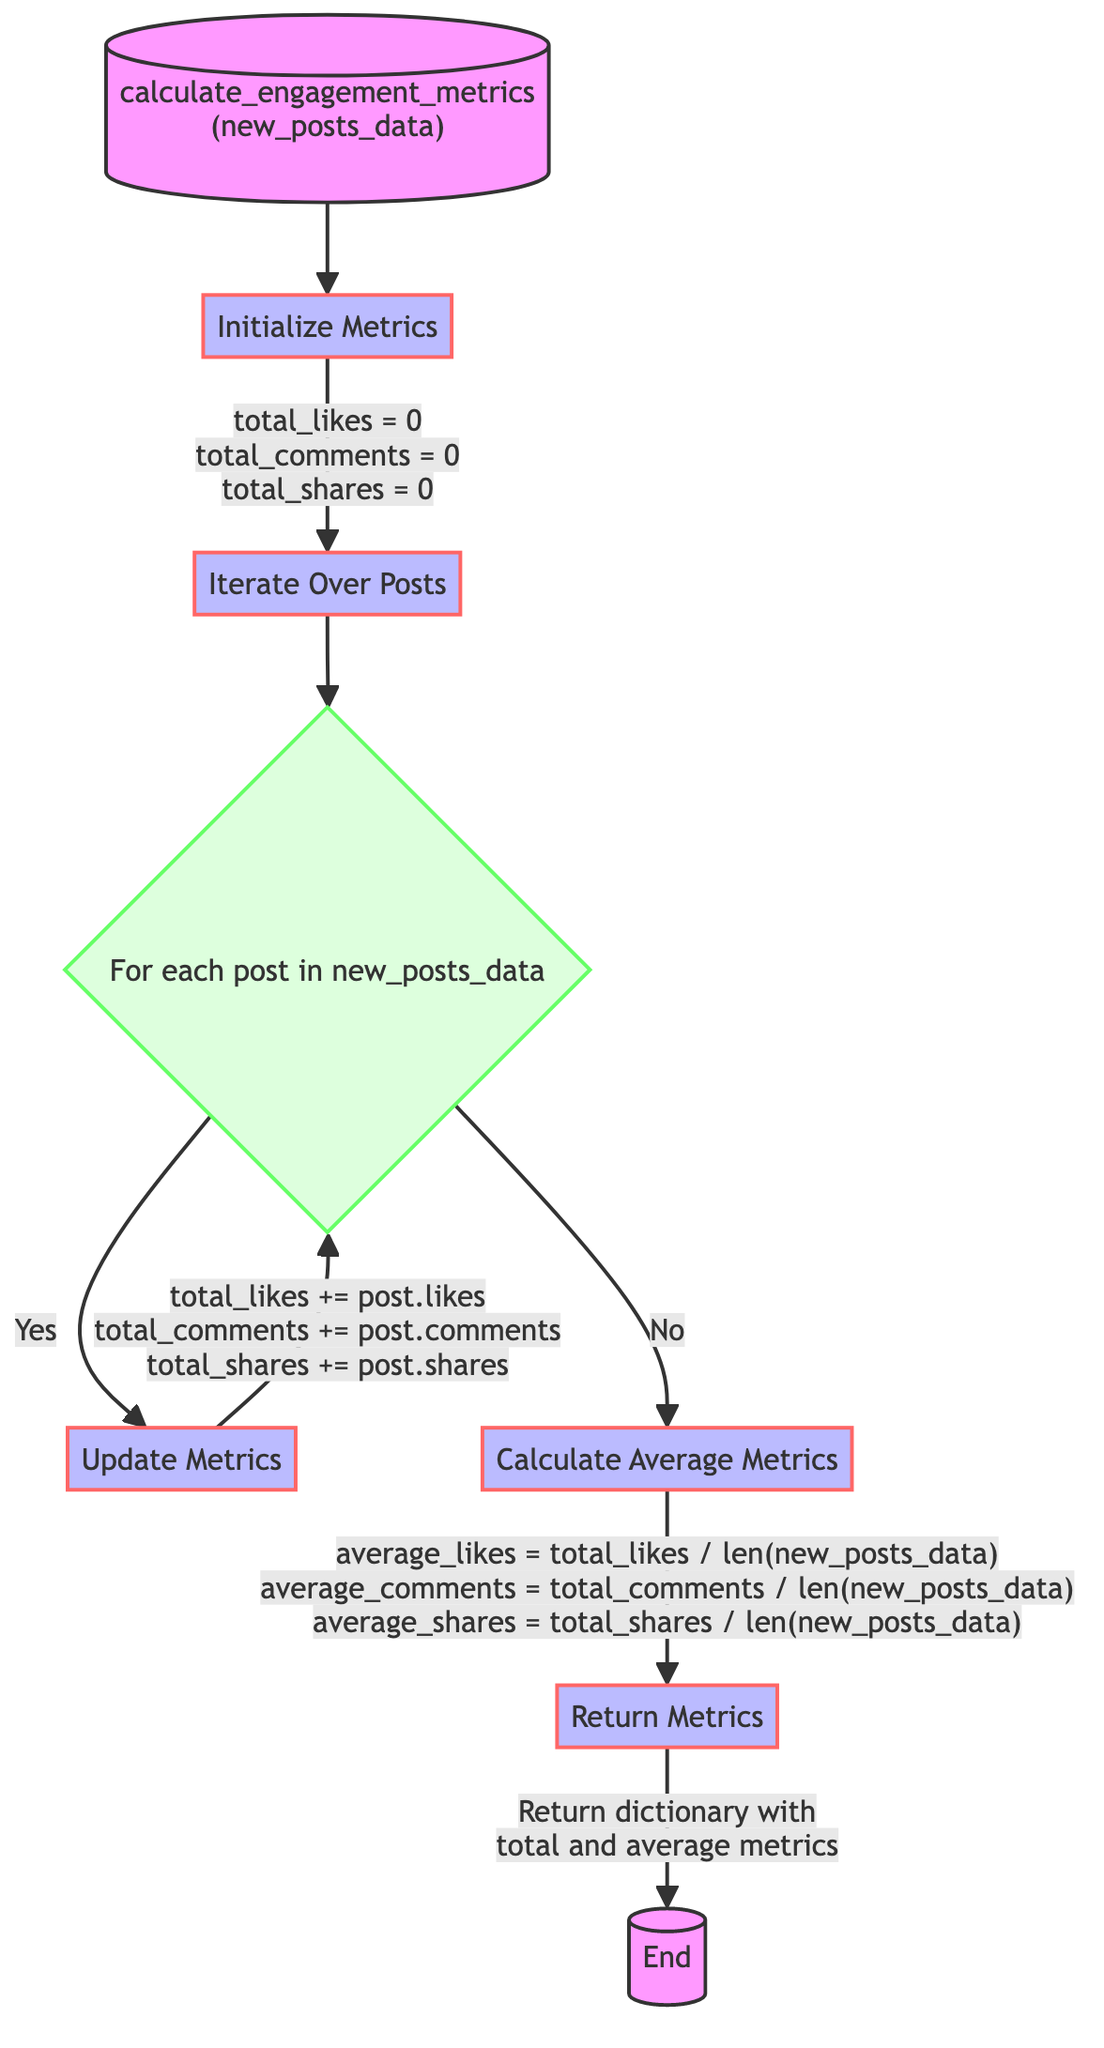What is the name of this function? The first node in the flowchart states the function name as "calculate_engagement_metrics", which indicates the purpose of the function.
Answer: calculate engagement metrics How many metric variables are initialized? The "Initialize Metrics" step shows that three variables are set to zero: total_likes, total_comments, and total_shares. Thus, counting these gives a total of three.
Answer: 3 What operation is performed in the "Update Metrics" step? In the "Update Metrics" step, the operation described is to add the likes, comments, and shares of each post to their corresponding total variables.
Answer: Add post's likes, comments, shares What is returned by the function? The final step states that the function returns a dictionary containing total and average metrics.
Answer: A dictionary with total and average metrics How is the average likes calculated? In the "Calculate Average Metrics" step, the formula provided for average likes is total_likes divided by the number of posts, derived from the length of new_posts_data.
Answer: total_likes / len(new_posts_data) At which step does the function decide if there are more posts? The function decides if there are more posts in the "Iterate Over Posts" step, where it checks if it should continue iterating or move to the next operation.
Answer: Iterate Over Posts What happens if there are no more posts? If there are no more posts, indicated by the "No" branch in the flowchart, the function proceeds to the "Calculate Average Metrics" step.
Answer: Proceeds to Calculate Average Metrics What type of data structure is returned at the end? The end of the diagram specifies that the function returns a dictionary, which is a data structure used to store key-value pairs.
Answer: Dictionary 